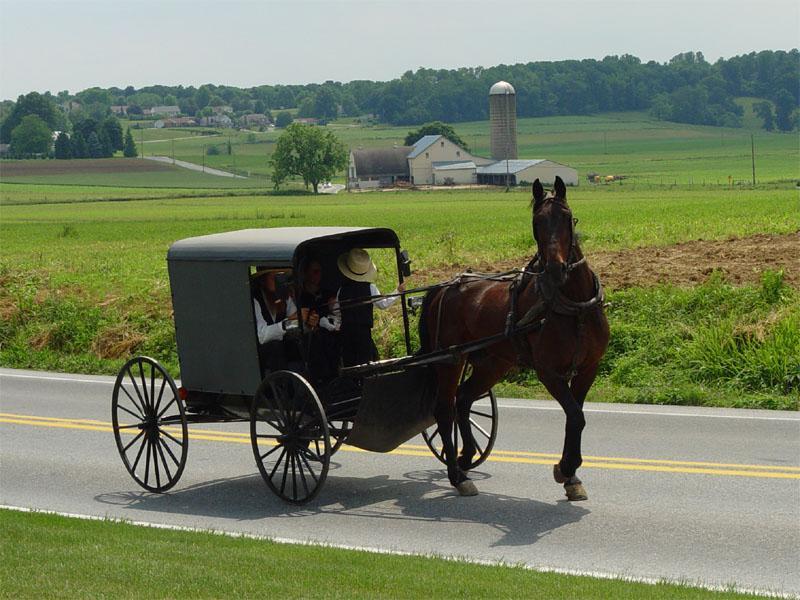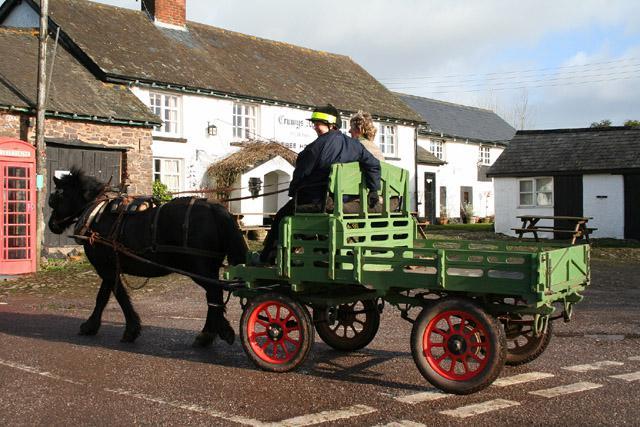The first image is the image on the left, the second image is the image on the right. Assess this claim about the two images: "All the carriages are facing left.". Correct or not? Answer yes or no. No. 